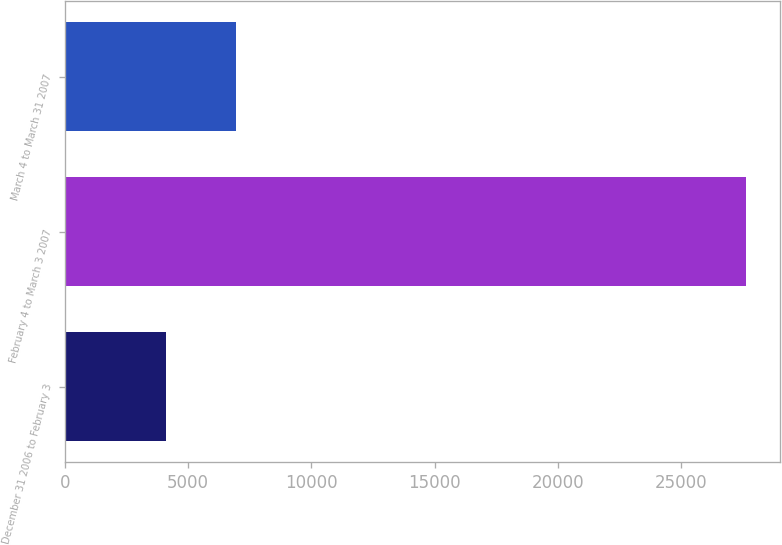Convert chart. <chart><loc_0><loc_0><loc_500><loc_500><bar_chart><fcel>December 31 2006 to February 3<fcel>February 4 to March 3 2007<fcel>March 4 to March 31 2007<nl><fcel>4109<fcel>27647<fcel>6950<nl></chart> 